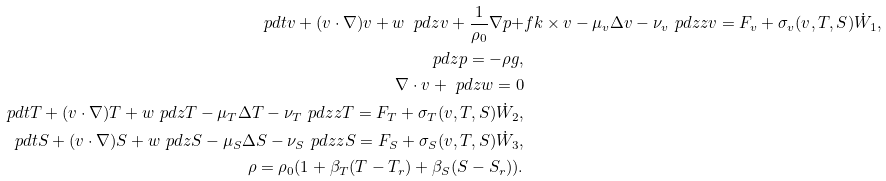Convert formula to latex. <formula><loc_0><loc_0><loc_500><loc_500>\ p d { t } v + ( v \cdot \nabla ) v + w \ p d { z } v + \frac { 1 } { \rho _ { 0 } } \nabla p + & f k \times v - \mu _ { v } \Delta v - \nu _ { v } \ p d { z z } v = F _ { v } + \sigma _ { v } ( v , T , S ) \dot { W } _ { 1 } , \\ \ p d { z } p = - \rho g , \\ \nabla \cdot v + \ p d { z } w = 0 \\ \ p d { t } T + ( v \cdot \nabla ) T + w \ p d { z } T - \mu _ { T } \Delta T - \nu _ { T } \ p d { z z } T = F _ { T } + \sigma _ { T } ( v , T , S ) \dot { W } _ { 2 } , \\ \ p d { t } S + ( v \cdot \nabla ) S + w \ p d { z } S - \mu _ { S } \Delta S - \nu _ { S } \ p d { z z } S = F _ { S } + \sigma _ { S } ( v , T , S ) \dot { W } _ { 3 } , \\ \rho = \rho _ { 0 } ( 1 + \beta _ { T } ( T - T _ { r } ) + \beta _ { S } ( S - S _ { r } ) ) .</formula> 